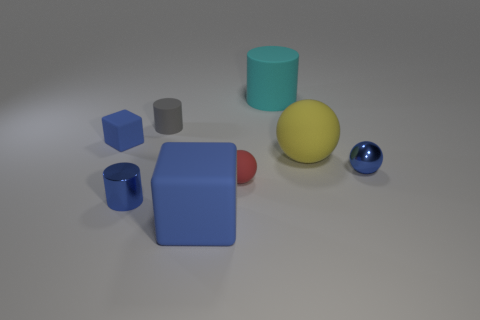What number of spheres are either gray matte things or blue matte things?
Provide a succinct answer. 0. Is the color of the large matte thing left of the large cyan object the same as the tiny metallic ball?
Provide a succinct answer. Yes. What material is the blue block behind the blue rubber thing that is right of the small cylinder in front of the large matte ball made of?
Your response must be concise. Rubber. Is the gray rubber object the same size as the yellow rubber object?
Offer a terse response. No. Does the shiny ball have the same color as the tiny metallic thing that is on the left side of the red sphere?
Your answer should be very brief. Yes. The tiny blue thing that is the same material as the blue sphere is what shape?
Give a very brief answer. Cylinder. There is a object to the right of the large yellow matte ball; does it have the same shape as the tiny red thing?
Keep it short and to the point. Yes. There is a blue block in front of the rubber sphere that is left of the big cyan object; what size is it?
Your answer should be compact. Large. There is a large block that is made of the same material as the gray thing; what is its color?
Keep it short and to the point. Blue. What number of red balls have the same size as the cyan matte cylinder?
Ensure brevity in your answer.  0. 